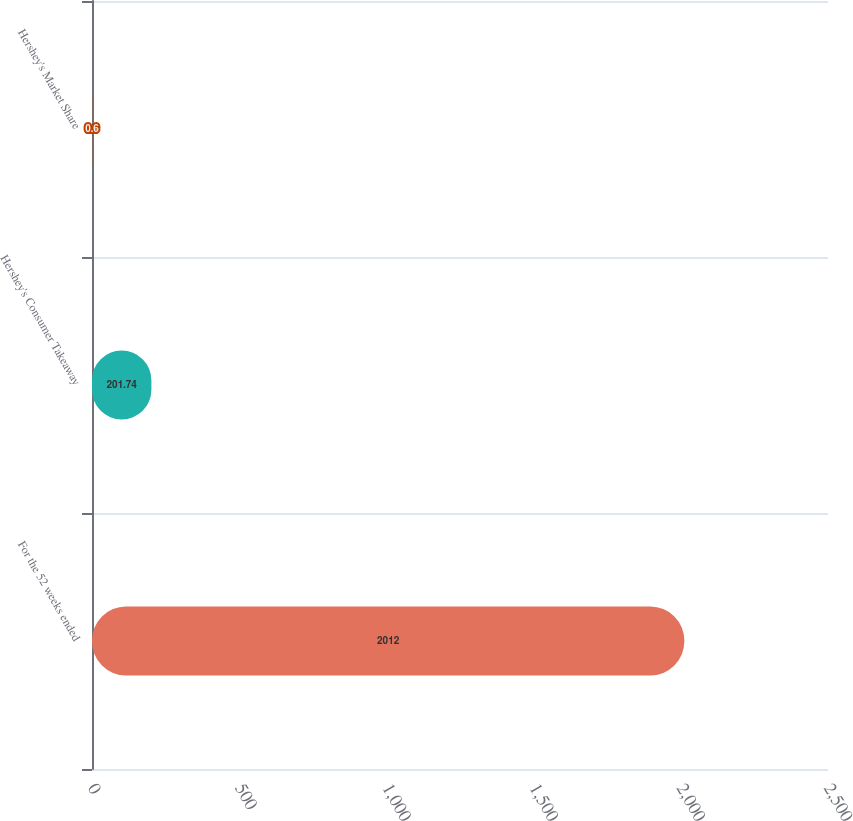<chart> <loc_0><loc_0><loc_500><loc_500><bar_chart><fcel>For the 52 weeks ended<fcel>Hershey's Consumer Takeaway<fcel>Hershey's Market Share<nl><fcel>2012<fcel>201.74<fcel>0.6<nl></chart> 